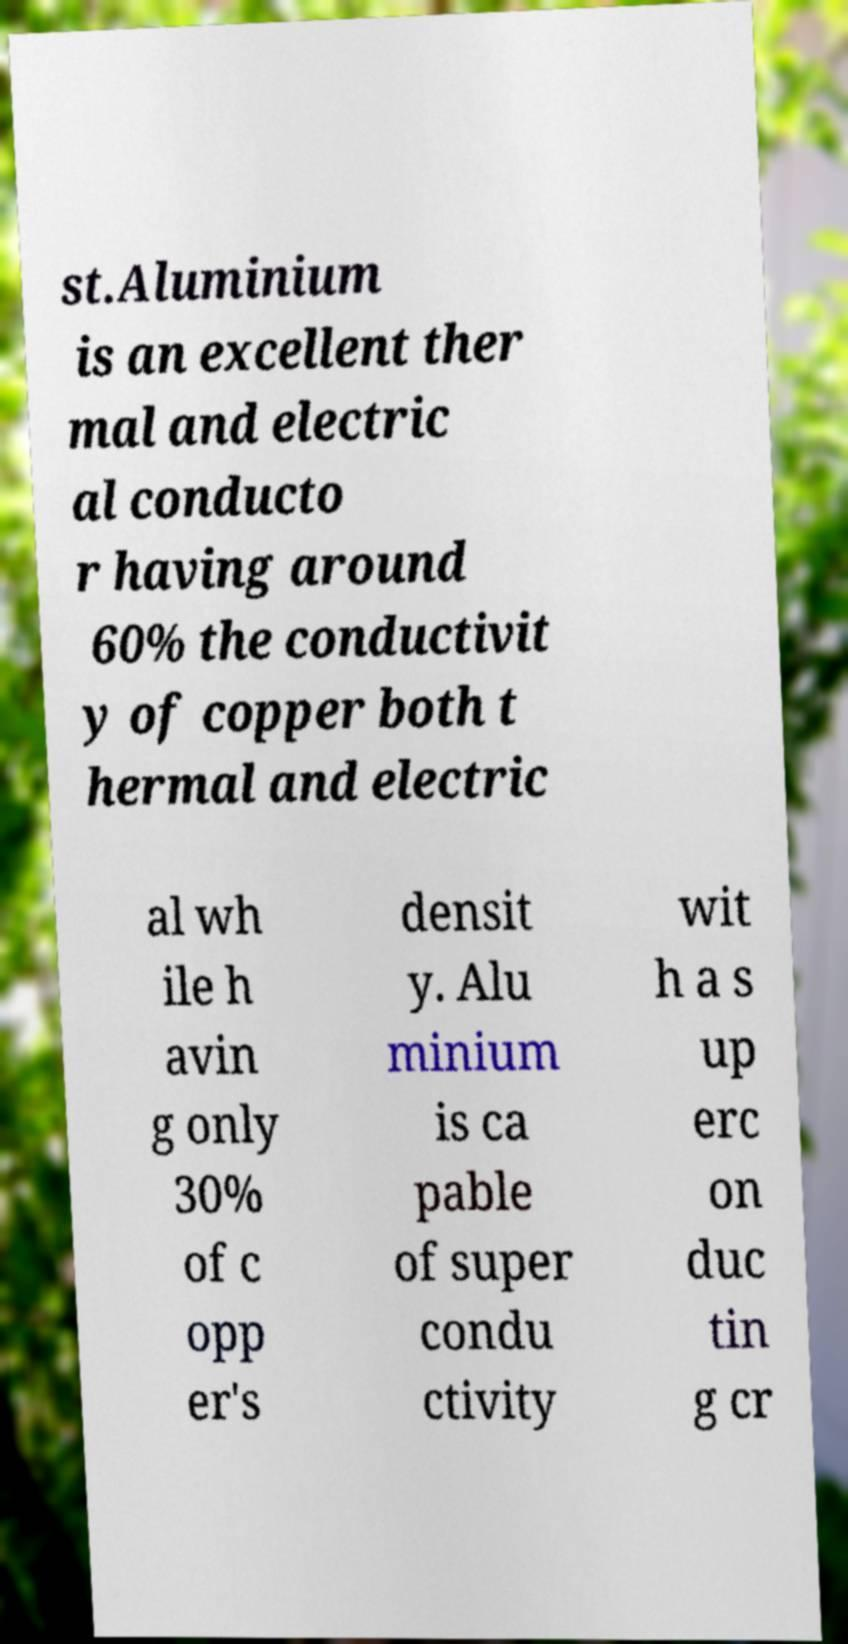Could you assist in decoding the text presented in this image and type it out clearly? st.Aluminium is an excellent ther mal and electric al conducto r having around 60% the conductivit y of copper both t hermal and electric al wh ile h avin g only 30% of c opp er's densit y. Alu minium is ca pable of super condu ctivity wit h a s up erc on duc tin g cr 